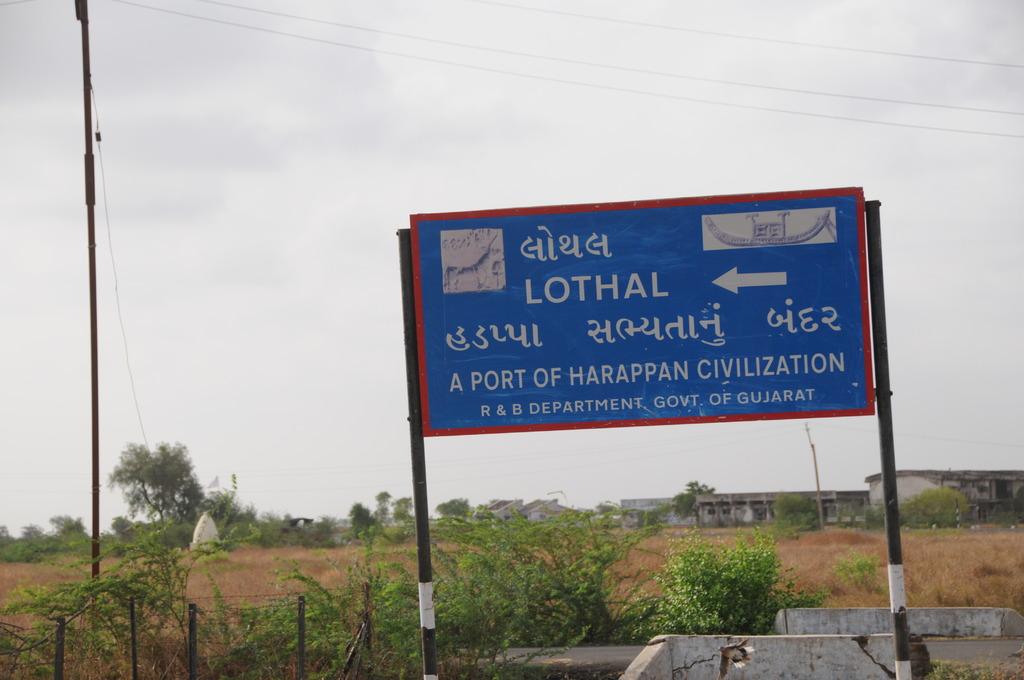What kind of port?
Your answer should be compact. Harappan civilization. 